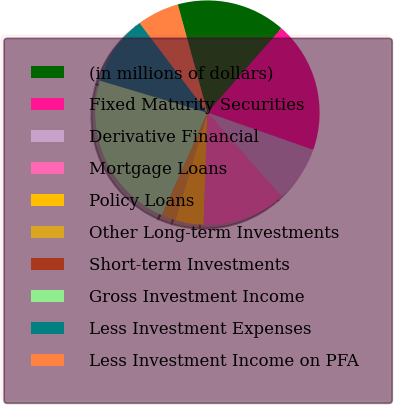Convert chart. <chart><loc_0><loc_0><loc_500><loc_500><pie_chart><fcel>(in millions of dollars)<fcel>Fixed Maturity Securities<fcel>Derivative Financial<fcel>Mortgage Loans<fcel>Policy Loans<fcel>Other Long-term Investments<fcel>Short-term Investments<fcel>Gross Investment Income<fcel>Less Investment Expenses<fcel>Less Investment Income on PFA<nl><fcel>15.7%<fcel>18.94%<fcel>8.07%<fcel>12.09%<fcel>4.05%<fcel>2.03%<fcel>0.02%<fcel>22.96%<fcel>10.08%<fcel>6.06%<nl></chart> 